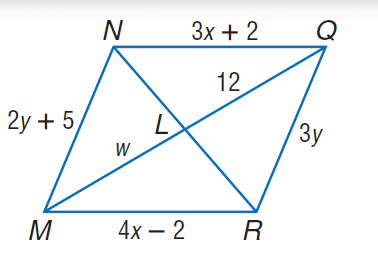Answer the mathemtical geometry problem and directly provide the correct option letter.
Question: Use parallelogram N Q R M to find x.
Choices: A: 4 B: 12 C: 14 D: 29 A 